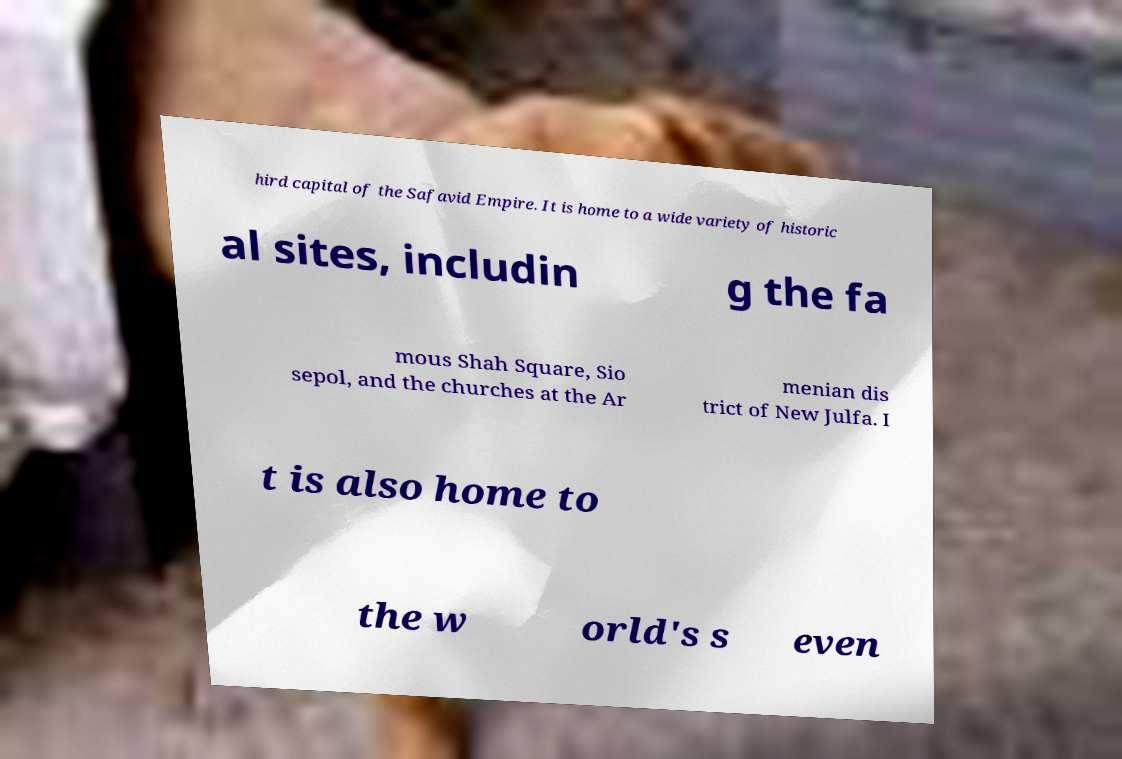What messages or text are displayed in this image? I need them in a readable, typed format. hird capital of the Safavid Empire. It is home to a wide variety of historic al sites, includin g the fa mous Shah Square, Sio sepol, and the churches at the Ar menian dis trict of New Julfa. I t is also home to the w orld's s even 